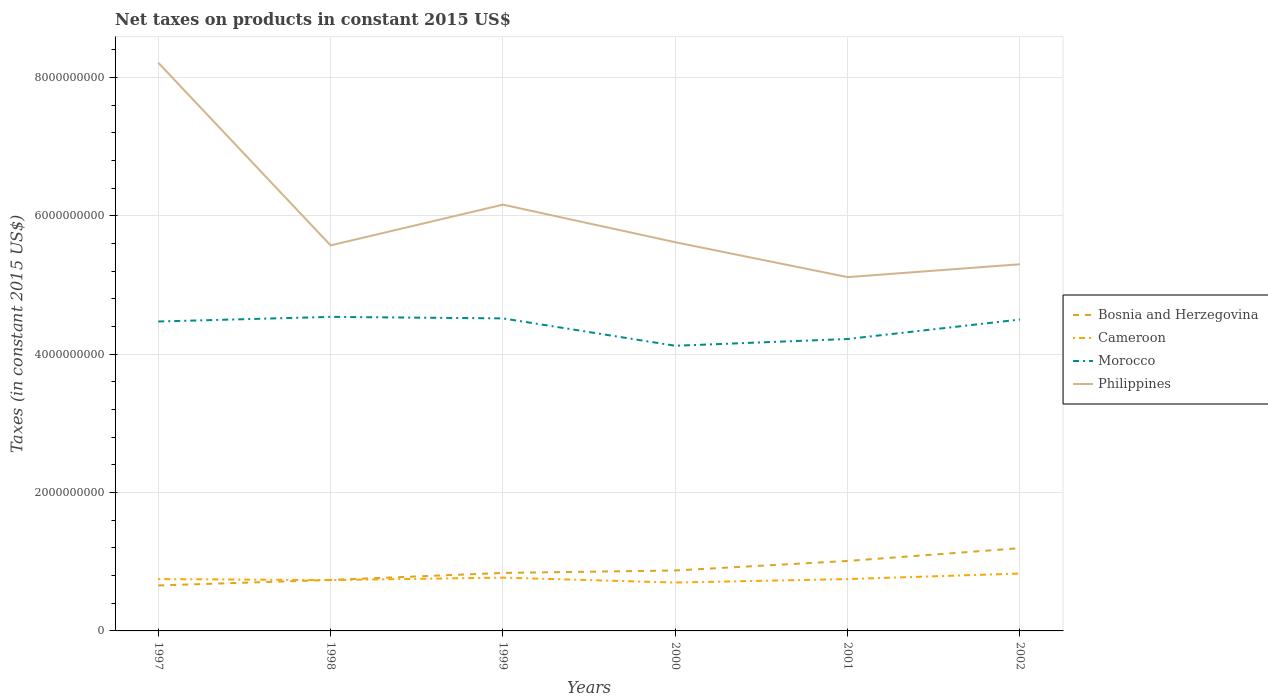Does the line corresponding to Bosnia and Herzegovina intersect with the line corresponding to Cameroon?
Provide a short and direct response. Yes. Is the number of lines equal to the number of legend labels?
Provide a succinct answer. Yes. Across all years, what is the maximum net taxes on products in Philippines?
Make the answer very short. 5.11e+09. In which year was the net taxes on products in Cameroon maximum?
Offer a very short reply. 2000. What is the total net taxes on products in Bosnia and Herzegovina in the graph?
Your response must be concise. -2.75e+08. What is the difference between the highest and the second highest net taxes on products in Bosnia and Herzegovina?
Your response must be concise. 5.39e+08. Is the net taxes on products in Philippines strictly greater than the net taxes on products in Morocco over the years?
Make the answer very short. No. How many years are there in the graph?
Ensure brevity in your answer.  6. What is the difference between two consecutive major ticks on the Y-axis?
Your response must be concise. 2.00e+09. Are the values on the major ticks of Y-axis written in scientific E-notation?
Keep it short and to the point. No. Does the graph contain grids?
Ensure brevity in your answer.  Yes. Where does the legend appear in the graph?
Provide a short and direct response. Center right. How many legend labels are there?
Your answer should be very brief. 4. How are the legend labels stacked?
Your answer should be very brief. Vertical. What is the title of the graph?
Keep it short and to the point. Net taxes on products in constant 2015 US$. What is the label or title of the X-axis?
Provide a short and direct response. Years. What is the label or title of the Y-axis?
Offer a terse response. Taxes (in constant 2015 US$). What is the Taxes (in constant 2015 US$) of Bosnia and Herzegovina in 1997?
Make the answer very short. 6.57e+08. What is the Taxes (in constant 2015 US$) in Cameroon in 1997?
Your answer should be very brief. 7.50e+08. What is the Taxes (in constant 2015 US$) of Morocco in 1997?
Give a very brief answer. 4.47e+09. What is the Taxes (in constant 2015 US$) of Philippines in 1997?
Offer a terse response. 8.21e+09. What is the Taxes (in constant 2015 US$) of Bosnia and Herzegovina in 1998?
Keep it short and to the point. 7.37e+08. What is the Taxes (in constant 2015 US$) of Cameroon in 1998?
Offer a very short reply. 7.35e+08. What is the Taxes (in constant 2015 US$) of Morocco in 1998?
Ensure brevity in your answer.  4.54e+09. What is the Taxes (in constant 2015 US$) in Philippines in 1998?
Keep it short and to the point. 5.57e+09. What is the Taxes (in constant 2015 US$) of Bosnia and Herzegovina in 1999?
Your answer should be compact. 8.38e+08. What is the Taxes (in constant 2015 US$) of Cameroon in 1999?
Your answer should be compact. 7.70e+08. What is the Taxes (in constant 2015 US$) of Morocco in 1999?
Provide a short and direct response. 4.52e+09. What is the Taxes (in constant 2015 US$) of Philippines in 1999?
Your response must be concise. 6.16e+09. What is the Taxes (in constant 2015 US$) in Bosnia and Herzegovina in 2000?
Offer a terse response. 8.74e+08. What is the Taxes (in constant 2015 US$) of Cameroon in 2000?
Ensure brevity in your answer.  6.99e+08. What is the Taxes (in constant 2015 US$) in Morocco in 2000?
Offer a very short reply. 4.12e+09. What is the Taxes (in constant 2015 US$) in Philippines in 2000?
Your answer should be very brief. 5.62e+09. What is the Taxes (in constant 2015 US$) in Bosnia and Herzegovina in 2001?
Provide a succinct answer. 1.01e+09. What is the Taxes (in constant 2015 US$) of Cameroon in 2001?
Your response must be concise. 7.50e+08. What is the Taxes (in constant 2015 US$) in Morocco in 2001?
Your answer should be very brief. 4.22e+09. What is the Taxes (in constant 2015 US$) of Philippines in 2001?
Keep it short and to the point. 5.11e+09. What is the Taxes (in constant 2015 US$) of Bosnia and Herzegovina in 2002?
Offer a very short reply. 1.20e+09. What is the Taxes (in constant 2015 US$) in Cameroon in 2002?
Provide a succinct answer. 8.30e+08. What is the Taxes (in constant 2015 US$) in Morocco in 2002?
Offer a terse response. 4.50e+09. What is the Taxes (in constant 2015 US$) in Philippines in 2002?
Make the answer very short. 5.30e+09. Across all years, what is the maximum Taxes (in constant 2015 US$) in Bosnia and Herzegovina?
Give a very brief answer. 1.20e+09. Across all years, what is the maximum Taxes (in constant 2015 US$) of Cameroon?
Offer a terse response. 8.30e+08. Across all years, what is the maximum Taxes (in constant 2015 US$) of Morocco?
Offer a very short reply. 4.54e+09. Across all years, what is the maximum Taxes (in constant 2015 US$) in Philippines?
Keep it short and to the point. 8.21e+09. Across all years, what is the minimum Taxes (in constant 2015 US$) of Bosnia and Herzegovina?
Offer a very short reply. 6.57e+08. Across all years, what is the minimum Taxes (in constant 2015 US$) in Cameroon?
Offer a terse response. 6.99e+08. Across all years, what is the minimum Taxes (in constant 2015 US$) of Morocco?
Make the answer very short. 4.12e+09. Across all years, what is the minimum Taxes (in constant 2015 US$) in Philippines?
Your answer should be very brief. 5.11e+09. What is the total Taxes (in constant 2015 US$) of Bosnia and Herzegovina in the graph?
Provide a succinct answer. 5.31e+09. What is the total Taxes (in constant 2015 US$) of Cameroon in the graph?
Provide a short and direct response. 4.53e+09. What is the total Taxes (in constant 2015 US$) of Morocco in the graph?
Your answer should be very brief. 2.64e+1. What is the total Taxes (in constant 2015 US$) of Philippines in the graph?
Your response must be concise. 3.60e+1. What is the difference between the Taxes (in constant 2015 US$) of Bosnia and Herzegovina in 1997 and that in 1998?
Your answer should be compact. -7.96e+07. What is the difference between the Taxes (in constant 2015 US$) in Cameroon in 1997 and that in 1998?
Your response must be concise. 1.47e+07. What is the difference between the Taxes (in constant 2015 US$) in Morocco in 1997 and that in 1998?
Your answer should be very brief. -6.67e+07. What is the difference between the Taxes (in constant 2015 US$) of Philippines in 1997 and that in 1998?
Your answer should be very brief. 2.64e+09. What is the difference between the Taxes (in constant 2015 US$) in Bosnia and Herzegovina in 1997 and that in 1999?
Ensure brevity in your answer.  -1.81e+08. What is the difference between the Taxes (in constant 2015 US$) in Cameroon in 1997 and that in 1999?
Keep it short and to the point. -2.08e+07. What is the difference between the Taxes (in constant 2015 US$) in Morocco in 1997 and that in 1999?
Provide a short and direct response. -4.49e+07. What is the difference between the Taxes (in constant 2015 US$) in Philippines in 1997 and that in 1999?
Keep it short and to the point. 2.05e+09. What is the difference between the Taxes (in constant 2015 US$) in Bosnia and Herzegovina in 1997 and that in 2000?
Make the answer very short. -2.17e+08. What is the difference between the Taxes (in constant 2015 US$) of Cameroon in 1997 and that in 2000?
Offer a terse response. 5.03e+07. What is the difference between the Taxes (in constant 2015 US$) in Morocco in 1997 and that in 2000?
Offer a very short reply. 3.51e+08. What is the difference between the Taxes (in constant 2015 US$) in Philippines in 1997 and that in 2000?
Give a very brief answer. 2.60e+09. What is the difference between the Taxes (in constant 2015 US$) of Bosnia and Herzegovina in 1997 and that in 2001?
Offer a very short reply. -3.54e+08. What is the difference between the Taxes (in constant 2015 US$) of Cameroon in 1997 and that in 2001?
Give a very brief answer. 3.57e+04. What is the difference between the Taxes (in constant 2015 US$) of Morocco in 1997 and that in 2001?
Ensure brevity in your answer.  2.53e+08. What is the difference between the Taxes (in constant 2015 US$) of Philippines in 1997 and that in 2001?
Give a very brief answer. 3.10e+09. What is the difference between the Taxes (in constant 2015 US$) of Bosnia and Herzegovina in 1997 and that in 2002?
Provide a succinct answer. -5.39e+08. What is the difference between the Taxes (in constant 2015 US$) in Cameroon in 1997 and that in 2002?
Ensure brevity in your answer.  -7.99e+07. What is the difference between the Taxes (in constant 2015 US$) of Morocco in 1997 and that in 2002?
Keep it short and to the point. -2.85e+07. What is the difference between the Taxes (in constant 2015 US$) in Philippines in 1997 and that in 2002?
Offer a terse response. 2.91e+09. What is the difference between the Taxes (in constant 2015 US$) of Bosnia and Herzegovina in 1998 and that in 1999?
Offer a terse response. -1.02e+08. What is the difference between the Taxes (in constant 2015 US$) in Cameroon in 1998 and that in 1999?
Your answer should be compact. -3.55e+07. What is the difference between the Taxes (in constant 2015 US$) in Morocco in 1998 and that in 1999?
Your answer should be very brief. 2.18e+07. What is the difference between the Taxes (in constant 2015 US$) in Philippines in 1998 and that in 1999?
Your response must be concise. -5.89e+08. What is the difference between the Taxes (in constant 2015 US$) of Bosnia and Herzegovina in 1998 and that in 2000?
Offer a terse response. -1.37e+08. What is the difference between the Taxes (in constant 2015 US$) of Cameroon in 1998 and that in 2000?
Provide a succinct answer. 3.56e+07. What is the difference between the Taxes (in constant 2015 US$) in Morocco in 1998 and that in 2000?
Make the answer very short. 4.18e+08. What is the difference between the Taxes (in constant 2015 US$) in Philippines in 1998 and that in 2000?
Provide a succinct answer. -4.56e+07. What is the difference between the Taxes (in constant 2015 US$) of Bosnia and Herzegovina in 1998 and that in 2001?
Offer a very short reply. -2.75e+08. What is the difference between the Taxes (in constant 2015 US$) in Cameroon in 1998 and that in 2001?
Offer a terse response. -1.47e+07. What is the difference between the Taxes (in constant 2015 US$) of Morocco in 1998 and that in 2001?
Your answer should be compact. 3.20e+08. What is the difference between the Taxes (in constant 2015 US$) in Philippines in 1998 and that in 2001?
Provide a succinct answer. 4.59e+08. What is the difference between the Taxes (in constant 2015 US$) of Bosnia and Herzegovina in 1998 and that in 2002?
Your response must be concise. -4.60e+08. What is the difference between the Taxes (in constant 2015 US$) in Cameroon in 1998 and that in 2002?
Your response must be concise. -9.46e+07. What is the difference between the Taxes (in constant 2015 US$) of Morocco in 1998 and that in 2002?
Your answer should be compact. 3.82e+07. What is the difference between the Taxes (in constant 2015 US$) in Philippines in 1998 and that in 2002?
Your answer should be very brief. 2.73e+08. What is the difference between the Taxes (in constant 2015 US$) in Bosnia and Herzegovina in 1999 and that in 2000?
Provide a short and direct response. -3.54e+07. What is the difference between the Taxes (in constant 2015 US$) in Cameroon in 1999 and that in 2000?
Your response must be concise. 7.11e+07. What is the difference between the Taxes (in constant 2015 US$) of Morocco in 1999 and that in 2000?
Your response must be concise. 3.96e+08. What is the difference between the Taxes (in constant 2015 US$) in Philippines in 1999 and that in 2000?
Provide a short and direct response. 5.43e+08. What is the difference between the Taxes (in constant 2015 US$) of Bosnia and Herzegovina in 1999 and that in 2001?
Offer a terse response. -1.73e+08. What is the difference between the Taxes (in constant 2015 US$) of Cameroon in 1999 and that in 2001?
Offer a very short reply. 2.08e+07. What is the difference between the Taxes (in constant 2015 US$) in Morocco in 1999 and that in 2001?
Your answer should be very brief. 2.98e+08. What is the difference between the Taxes (in constant 2015 US$) in Philippines in 1999 and that in 2001?
Provide a short and direct response. 1.05e+09. What is the difference between the Taxes (in constant 2015 US$) in Bosnia and Herzegovina in 1999 and that in 2002?
Make the answer very short. -3.58e+08. What is the difference between the Taxes (in constant 2015 US$) in Cameroon in 1999 and that in 2002?
Offer a very short reply. -5.92e+07. What is the difference between the Taxes (in constant 2015 US$) of Morocco in 1999 and that in 2002?
Give a very brief answer. 1.64e+07. What is the difference between the Taxes (in constant 2015 US$) in Philippines in 1999 and that in 2002?
Provide a short and direct response. 8.62e+08. What is the difference between the Taxes (in constant 2015 US$) in Bosnia and Herzegovina in 2000 and that in 2001?
Your response must be concise. -1.38e+08. What is the difference between the Taxes (in constant 2015 US$) of Cameroon in 2000 and that in 2001?
Ensure brevity in your answer.  -5.02e+07. What is the difference between the Taxes (in constant 2015 US$) in Morocco in 2000 and that in 2001?
Keep it short and to the point. -9.79e+07. What is the difference between the Taxes (in constant 2015 US$) in Philippines in 2000 and that in 2001?
Your response must be concise. 5.04e+08. What is the difference between the Taxes (in constant 2015 US$) of Bosnia and Herzegovina in 2000 and that in 2002?
Offer a terse response. -3.23e+08. What is the difference between the Taxes (in constant 2015 US$) in Cameroon in 2000 and that in 2002?
Your answer should be very brief. -1.30e+08. What is the difference between the Taxes (in constant 2015 US$) in Morocco in 2000 and that in 2002?
Keep it short and to the point. -3.79e+08. What is the difference between the Taxes (in constant 2015 US$) of Philippines in 2000 and that in 2002?
Your answer should be very brief. 3.18e+08. What is the difference between the Taxes (in constant 2015 US$) in Bosnia and Herzegovina in 2001 and that in 2002?
Your response must be concise. -1.85e+08. What is the difference between the Taxes (in constant 2015 US$) of Cameroon in 2001 and that in 2002?
Make the answer very short. -8.00e+07. What is the difference between the Taxes (in constant 2015 US$) in Morocco in 2001 and that in 2002?
Your answer should be very brief. -2.81e+08. What is the difference between the Taxes (in constant 2015 US$) of Philippines in 2001 and that in 2002?
Your answer should be compact. -1.86e+08. What is the difference between the Taxes (in constant 2015 US$) of Bosnia and Herzegovina in 1997 and the Taxes (in constant 2015 US$) of Cameroon in 1998?
Offer a terse response. -7.77e+07. What is the difference between the Taxes (in constant 2015 US$) of Bosnia and Herzegovina in 1997 and the Taxes (in constant 2015 US$) of Morocco in 1998?
Provide a short and direct response. -3.88e+09. What is the difference between the Taxes (in constant 2015 US$) in Bosnia and Herzegovina in 1997 and the Taxes (in constant 2015 US$) in Philippines in 1998?
Your answer should be very brief. -4.92e+09. What is the difference between the Taxes (in constant 2015 US$) in Cameroon in 1997 and the Taxes (in constant 2015 US$) in Morocco in 1998?
Ensure brevity in your answer.  -3.79e+09. What is the difference between the Taxes (in constant 2015 US$) in Cameroon in 1997 and the Taxes (in constant 2015 US$) in Philippines in 1998?
Your response must be concise. -4.82e+09. What is the difference between the Taxes (in constant 2015 US$) in Morocco in 1997 and the Taxes (in constant 2015 US$) in Philippines in 1998?
Give a very brief answer. -1.10e+09. What is the difference between the Taxes (in constant 2015 US$) in Bosnia and Herzegovina in 1997 and the Taxes (in constant 2015 US$) in Cameroon in 1999?
Provide a succinct answer. -1.13e+08. What is the difference between the Taxes (in constant 2015 US$) in Bosnia and Herzegovina in 1997 and the Taxes (in constant 2015 US$) in Morocco in 1999?
Give a very brief answer. -3.86e+09. What is the difference between the Taxes (in constant 2015 US$) of Bosnia and Herzegovina in 1997 and the Taxes (in constant 2015 US$) of Philippines in 1999?
Give a very brief answer. -5.51e+09. What is the difference between the Taxes (in constant 2015 US$) in Cameroon in 1997 and the Taxes (in constant 2015 US$) in Morocco in 1999?
Give a very brief answer. -3.77e+09. What is the difference between the Taxes (in constant 2015 US$) in Cameroon in 1997 and the Taxes (in constant 2015 US$) in Philippines in 1999?
Offer a very short reply. -5.41e+09. What is the difference between the Taxes (in constant 2015 US$) of Morocco in 1997 and the Taxes (in constant 2015 US$) of Philippines in 1999?
Offer a terse response. -1.69e+09. What is the difference between the Taxes (in constant 2015 US$) of Bosnia and Herzegovina in 1997 and the Taxes (in constant 2015 US$) of Cameroon in 2000?
Your response must be concise. -4.21e+07. What is the difference between the Taxes (in constant 2015 US$) in Bosnia and Herzegovina in 1997 and the Taxes (in constant 2015 US$) in Morocco in 2000?
Offer a very short reply. -3.47e+09. What is the difference between the Taxes (in constant 2015 US$) of Bosnia and Herzegovina in 1997 and the Taxes (in constant 2015 US$) of Philippines in 2000?
Provide a succinct answer. -4.96e+09. What is the difference between the Taxes (in constant 2015 US$) in Cameroon in 1997 and the Taxes (in constant 2015 US$) in Morocco in 2000?
Your answer should be very brief. -3.37e+09. What is the difference between the Taxes (in constant 2015 US$) of Cameroon in 1997 and the Taxes (in constant 2015 US$) of Philippines in 2000?
Your response must be concise. -4.87e+09. What is the difference between the Taxes (in constant 2015 US$) of Morocco in 1997 and the Taxes (in constant 2015 US$) of Philippines in 2000?
Provide a short and direct response. -1.15e+09. What is the difference between the Taxes (in constant 2015 US$) of Bosnia and Herzegovina in 1997 and the Taxes (in constant 2015 US$) of Cameroon in 2001?
Your answer should be very brief. -9.23e+07. What is the difference between the Taxes (in constant 2015 US$) of Bosnia and Herzegovina in 1997 and the Taxes (in constant 2015 US$) of Morocco in 2001?
Keep it short and to the point. -3.56e+09. What is the difference between the Taxes (in constant 2015 US$) of Bosnia and Herzegovina in 1997 and the Taxes (in constant 2015 US$) of Philippines in 2001?
Your answer should be compact. -4.46e+09. What is the difference between the Taxes (in constant 2015 US$) of Cameroon in 1997 and the Taxes (in constant 2015 US$) of Morocco in 2001?
Your answer should be very brief. -3.47e+09. What is the difference between the Taxes (in constant 2015 US$) of Cameroon in 1997 and the Taxes (in constant 2015 US$) of Philippines in 2001?
Offer a very short reply. -4.37e+09. What is the difference between the Taxes (in constant 2015 US$) in Morocco in 1997 and the Taxes (in constant 2015 US$) in Philippines in 2001?
Provide a short and direct response. -6.42e+08. What is the difference between the Taxes (in constant 2015 US$) in Bosnia and Herzegovina in 1997 and the Taxes (in constant 2015 US$) in Cameroon in 2002?
Make the answer very short. -1.72e+08. What is the difference between the Taxes (in constant 2015 US$) in Bosnia and Herzegovina in 1997 and the Taxes (in constant 2015 US$) in Morocco in 2002?
Make the answer very short. -3.84e+09. What is the difference between the Taxes (in constant 2015 US$) of Bosnia and Herzegovina in 1997 and the Taxes (in constant 2015 US$) of Philippines in 2002?
Provide a short and direct response. -4.64e+09. What is the difference between the Taxes (in constant 2015 US$) in Cameroon in 1997 and the Taxes (in constant 2015 US$) in Morocco in 2002?
Give a very brief answer. -3.75e+09. What is the difference between the Taxes (in constant 2015 US$) of Cameroon in 1997 and the Taxes (in constant 2015 US$) of Philippines in 2002?
Provide a succinct answer. -4.55e+09. What is the difference between the Taxes (in constant 2015 US$) in Morocco in 1997 and the Taxes (in constant 2015 US$) in Philippines in 2002?
Ensure brevity in your answer.  -8.28e+08. What is the difference between the Taxes (in constant 2015 US$) of Bosnia and Herzegovina in 1998 and the Taxes (in constant 2015 US$) of Cameroon in 1999?
Your answer should be very brief. -3.35e+07. What is the difference between the Taxes (in constant 2015 US$) of Bosnia and Herzegovina in 1998 and the Taxes (in constant 2015 US$) of Morocco in 1999?
Ensure brevity in your answer.  -3.78e+09. What is the difference between the Taxes (in constant 2015 US$) in Bosnia and Herzegovina in 1998 and the Taxes (in constant 2015 US$) in Philippines in 1999?
Keep it short and to the point. -5.43e+09. What is the difference between the Taxes (in constant 2015 US$) of Cameroon in 1998 and the Taxes (in constant 2015 US$) of Morocco in 1999?
Your answer should be compact. -3.78e+09. What is the difference between the Taxes (in constant 2015 US$) in Cameroon in 1998 and the Taxes (in constant 2015 US$) in Philippines in 1999?
Offer a terse response. -5.43e+09. What is the difference between the Taxes (in constant 2015 US$) of Morocco in 1998 and the Taxes (in constant 2015 US$) of Philippines in 1999?
Keep it short and to the point. -1.62e+09. What is the difference between the Taxes (in constant 2015 US$) in Bosnia and Herzegovina in 1998 and the Taxes (in constant 2015 US$) in Cameroon in 2000?
Offer a terse response. 3.76e+07. What is the difference between the Taxes (in constant 2015 US$) in Bosnia and Herzegovina in 1998 and the Taxes (in constant 2015 US$) in Morocco in 2000?
Your answer should be very brief. -3.39e+09. What is the difference between the Taxes (in constant 2015 US$) of Bosnia and Herzegovina in 1998 and the Taxes (in constant 2015 US$) of Philippines in 2000?
Your response must be concise. -4.88e+09. What is the difference between the Taxes (in constant 2015 US$) in Cameroon in 1998 and the Taxes (in constant 2015 US$) in Morocco in 2000?
Your answer should be compact. -3.39e+09. What is the difference between the Taxes (in constant 2015 US$) of Cameroon in 1998 and the Taxes (in constant 2015 US$) of Philippines in 2000?
Your response must be concise. -4.88e+09. What is the difference between the Taxes (in constant 2015 US$) in Morocco in 1998 and the Taxes (in constant 2015 US$) in Philippines in 2000?
Your answer should be compact. -1.08e+09. What is the difference between the Taxes (in constant 2015 US$) of Bosnia and Herzegovina in 1998 and the Taxes (in constant 2015 US$) of Cameroon in 2001?
Ensure brevity in your answer.  -1.27e+07. What is the difference between the Taxes (in constant 2015 US$) of Bosnia and Herzegovina in 1998 and the Taxes (in constant 2015 US$) of Morocco in 2001?
Make the answer very short. -3.48e+09. What is the difference between the Taxes (in constant 2015 US$) in Bosnia and Herzegovina in 1998 and the Taxes (in constant 2015 US$) in Philippines in 2001?
Offer a terse response. -4.38e+09. What is the difference between the Taxes (in constant 2015 US$) of Cameroon in 1998 and the Taxes (in constant 2015 US$) of Morocco in 2001?
Give a very brief answer. -3.49e+09. What is the difference between the Taxes (in constant 2015 US$) of Cameroon in 1998 and the Taxes (in constant 2015 US$) of Philippines in 2001?
Offer a terse response. -4.38e+09. What is the difference between the Taxes (in constant 2015 US$) of Morocco in 1998 and the Taxes (in constant 2015 US$) of Philippines in 2001?
Your answer should be compact. -5.75e+08. What is the difference between the Taxes (in constant 2015 US$) of Bosnia and Herzegovina in 1998 and the Taxes (in constant 2015 US$) of Cameroon in 2002?
Your response must be concise. -9.27e+07. What is the difference between the Taxes (in constant 2015 US$) in Bosnia and Herzegovina in 1998 and the Taxes (in constant 2015 US$) in Morocco in 2002?
Provide a succinct answer. -3.76e+09. What is the difference between the Taxes (in constant 2015 US$) in Bosnia and Herzegovina in 1998 and the Taxes (in constant 2015 US$) in Philippines in 2002?
Ensure brevity in your answer.  -4.56e+09. What is the difference between the Taxes (in constant 2015 US$) of Cameroon in 1998 and the Taxes (in constant 2015 US$) of Morocco in 2002?
Provide a short and direct response. -3.77e+09. What is the difference between the Taxes (in constant 2015 US$) in Cameroon in 1998 and the Taxes (in constant 2015 US$) in Philippines in 2002?
Offer a very short reply. -4.57e+09. What is the difference between the Taxes (in constant 2015 US$) in Morocco in 1998 and the Taxes (in constant 2015 US$) in Philippines in 2002?
Make the answer very short. -7.61e+08. What is the difference between the Taxes (in constant 2015 US$) of Bosnia and Herzegovina in 1999 and the Taxes (in constant 2015 US$) of Cameroon in 2000?
Offer a terse response. 1.39e+08. What is the difference between the Taxes (in constant 2015 US$) in Bosnia and Herzegovina in 1999 and the Taxes (in constant 2015 US$) in Morocco in 2000?
Offer a terse response. -3.28e+09. What is the difference between the Taxes (in constant 2015 US$) of Bosnia and Herzegovina in 1999 and the Taxes (in constant 2015 US$) of Philippines in 2000?
Your answer should be very brief. -4.78e+09. What is the difference between the Taxes (in constant 2015 US$) of Cameroon in 1999 and the Taxes (in constant 2015 US$) of Morocco in 2000?
Your answer should be very brief. -3.35e+09. What is the difference between the Taxes (in constant 2015 US$) of Cameroon in 1999 and the Taxes (in constant 2015 US$) of Philippines in 2000?
Make the answer very short. -4.85e+09. What is the difference between the Taxes (in constant 2015 US$) of Morocco in 1999 and the Taxes (in constant 2015 US$) of Philippines in 2000?
Offer a terse response. -1.10e+09. What is the difference between the Taxes (in constant 2015 US$) of Bosnia and Herzegovina in 1999 and the Taxes (in constant 2015 US$) of Cameroon in 2001?
Provide a succinct answer. 8.88e+07. What is the difference between the Taxes (in constant 2015 US$) in Bosnia and Herzegovina in 1999 and the Taxes (in constant 2015 US$) in Morocco in 2001?
Offer a very short reply. -3.38e+09. What is the difference between the Taxes (in constant 2015 US$) of Bosnia and Herzegovina in 1999 and the Taxes (in constant 2015 US$) of Philippines in 2001?
Provide a short and direct response. -4.28e+09. What is the difference between the Taxes (in constant 2015 US$) of Cameroon in 1999 and the Taxes (in constant 2015 US$) of Morocco in 2001?
Provide a short and direct response. -3.45e+09. What is the difference between the Taxes (in constant 2015 US$) of Cameroon in 1999 and the Taxes (in constant 2015 US$) of Philippines in 2001?
Offer a terse response. -4.34e+09. What is the difference between the Taxes (in constant 2015 US$) of Morocco in 1999 and the Taxes (in constant 2015 US$) of Philippines in 2001?
Keep it short and to the point. -5.97e+08. What is the difference between the Taxes (in constant 2015 US$) in Bosnia and Herzegovina in 1999 and the Taxes (in constant 2015 US$) in Cameroon in 2002?
Provide a short and direct response. 8.86e+06. What is the difference between the Taxes (in constant 2015 US$) in Bosnia and Herzegovina in 1999 and the Taxes (in constant 2015 US$) in Morocco in 2002?
Your answer should be compact. -3.66e+09. What is the difference between the Taxes (in constant 2015 US$) in Bosnia and Herzegovina in 1999 and the Taxes (in constant 2015 US$) in Philippines in 2002?
Your answer should be very brief. -4.46e+09. What is the difference between the Taxes (in constant 2015 US$) in Cameroon in 1999 and the Taxes (in constant 2015 US$) in Morocco in 2002?
Provide a short and direct response. -3.73e+09. What is the difference between the Taxes (in constant 2015 US$) in Cameroon in 1999 and the Taxes (in constant 2015 US$) in Philippines in 2002?
Your answer should be compact. -4.53e+09. What is the difference between the Taxes (in constant 2015 US$) in Morocco in 1999 and the Taxes (in constant 2015 US$) in Philippines in 2002?
Your response must be concise. -7.83e+08. What is the difference between the Taxes (in constant 2015 US$) of Bosnia and Herzegovina in 2000 and the Taxes (in constant 2015 US$) of Cameroon in 2001?
Provide a short and direct response. 1.24e+08. What is the difference between the Taxes (in constant 2015 US$) of Bosnia and Herzegovina in 2000 and the Taxes (in constant 2015 US$) of Morocco in 2001?
Your response must be concise. -3.35e+09. What is the difference between the Taxes (in constant 2015 US$) in Bosnia and Herzegovina in 2000 and the Taxes (in constant 2015 US$) in Philippines in 2001?
Make the answer very short. -4.24e+09. What is the difference between the Taxes (in constant 2015 US$) of Cameroon in 2000 and the Taxes (in constant 2015 US$) of Morocco in 2001?
Your answer should be very brief. -3.52e+09. What is the difference between the Taxes (in constant 2015 US$) of Cameroon in 2000 and the Taxes (in constant 2015 US$) of Philippines in 2001?
Provide a short and direct response. -4.42e+09. What is the difference between the Taxes (in constant 2015 US$) in Morocco in 2000 and the Taxes (in constant 2015 US$) in Philippines in 2001?
Provide a succinct answer. -9.92e+08. What is the difference between the Taxes (in constant 2015 US$) in Bosnia and Herzegovina in 2000 and the Taxes (in constant 2015 US$) in Cameroon in 2002?
Offer a terse response. 4.43e+07. What is the difference between the Taxes (in constant 2015 US$) in Bosnia and Herzegovina in 2000 and the Taxes (in constant 2015 US$) in Morocco in 2002?
Offer a very short reply. -3.63e+09. What is the difference between the Taxes (in constant 2015 US$) of Bosnia and Herzegovina in 2000 and the Taxes (in constant 2015 US$) of Philippines in 2002?
Give a very brief answer. -4.43e+09. What is the difference between the Taxes (in constant 2015 US$) of Cameroon in 2000 and the Taxes (in constant 2015 US$) of Morocco in 2002?
Provide a succinct answer. -3.80e+09. What is the difference between the Taxes (in constant 2015 US$) of Cameroon in 2000 and the Taxes (in constant 2015 US$) of Philippines in 2002?
Ensure brevity in your answer.  -4.60e+09. What is the difference between the Taxes (in constant 2015 US$) in Morocco in 2000 and the Taxes (in constant 2015 US$) in Philippines in 2002?
Ensure brevity in your answer.  -1.18e+09. What is the difference between the Taxes (in constant 2015 US$) in Bosnia and Herzegovina in 2001 and the Taxes (in constant 2015 US$) in Cameroon in 2002?
Give a very brief answer. 1.82e+08. What is the difference between the Taxes (in constant 2015 US$) of Bosnia and Herzegovina in 2001 and the Taxes (in constant 2015 US$) of Morocco in 2002?
Keep it short and to the point. -3.49e+09. What is the difference between the Taxes (in constant 2015 US$) in Bosnia and Herzegovina in 2001 and the Taxes (in constant 2015 US$) in Philippines in 2002?
Make the answer very short. -4.29e+09. What is the difference between the Taxes (in constant 2015 US$) of Cameroon in 2001 and the Taxes (in constant 2015 US$) of Morocco in 2002?
Provide a short and direct response. -3.75e+09. What is the difference between the Taxes (in constant 2015 US$) in Cameroon in 2001 and the Taxes (in constant 2015 US$) in Philippines in 2002?
Offer a terse response. -4.55e+09. What is the difference between the Taxes (in constant 2015 US$) in Morocco in 2001 and the Taxes (in constant 2015 US$) in Philippines in 2002?
Ensure brevity in your answer.  -1.08e+09. What is the average Taxes (in constant 2015 US$) in Bosnia and Herzegovina per year?
Keep it short and to the point. 8.86e+08. What is the average Taxes (in constant 2015 US$) of Cameroon per year?
Provide a short and direct response. 7.56e+08. What is the average Taxes (in constant 2015 US$) in Morocco per year?
Make the answer very short. 4.40e+09. What is the average Taxes (in constant 2015 US$) of Philippines per year?
Your response must be concise. 6.00e+09. In the year 1997, what is the difference between the Taxes (in constant 2015 US$) in Bosnia and Herzegovina and Taxes (in constant 2015 US$) in Cameroon?
Provide a short and direct response. -9.24e+07. In the year 1997, what is the difference between the Taxes (in constant 2015 US$) of Bosnia and Herzegovina and Taxes (in constant 2015 US$) of Morocco?
Ensure brevity in your answer.  -3.82e+09. In the year 1997, what is the difference between the Taxes (in constant 2015 US$) in Bosnia and Herzegovina and Taxes (in constant 2015 US$) in Philippines?
Make the answer very short. -7.56e+09. In the year 1997, what is the difference between the Taxes (in constant 2015 US$) in Cameroon and Taxes (in constant 2015 US$) in Morocco?
Make the answer very short. -3.72e+09. In the year 1997, what is the difference between the Taxes (in constant 2015 US$) of Cameroon and Taxes (in constant 2015 US$) of Philippines?
Ensure brevity in your answer.  -7.47e+09. In the year 1997, what is the difference between the Taxes (in constant 2015 US$) of Morocco and Taxes (in constant 2015 US$) of Philippines?
Provide a succinct answer. -3.74e+09. In the year 1998, what is the difference between the Taxes (in constant 2015 US$) in Bosnia and Herzegovina and Taxes (in constant 2015 US$) in Cameroon?
Offer a terse response. 1.97e+06. In the year 1998, what is the difference between the Taxes (in constant 2015 US$) of Bosnia and Herzegovina and Taxes (in constant 2015 US$) of Morocco?
Offer a terse response. -3.80e+09. In the year 1998, what is the difference between the Taxes (in constant 2015 US$) in Bosnia and Herzegovina and Taxes (in constant 2015 US$) in Philippines?
Provide a succinct answer. -4.84e+09. In the year 1998, what is the difference between the Taxes (in constant 2015 US$) of Cameroon and Taxes (in constant 2015 US$) of Morocco?
Offer a very short reply. -3.81e+09. In the year 1998, what is the difference between the Taxes (in constant 2015 US$) in Cameroon and Taxes (in constant 2015 US$) in Philippines?
Offer a very short reply. -4.84e+09. In the year 1998, what is the difference between the Taxes (in constant 2015 US$) of Morocco and Taxes (in constant 2015 US$) of Philippines?
Give a very brief answer. -1.03e+09. In the year 1999, what is the difference between the Taxes (in constant 2015 US$) of Bosnia and Herzegovina and Taxes (in constant 2015 US$) of Cameroon?
Ensure brevity in your answer.  6.80e+07. In the year 1999, what is the difference between the Taxes (in constant 2015 US$) in Bosnia and Herzegovina and Taxes (in constant 2015 US$) in Morocco?
Your answer should be compact. -3.68e+09. In the year 1999, what is the difference between the Taxes (in constant 2015 US$) in Bosnia and Herzegovina and Taxes (in constant 2015 US$) in Philippines?
Your answer should be compact. -5.32e+09. In the year 1999, what is the difference between the Taxes (in constant 2015 US$) in Cameroon and Taxes (in constant 2015 US$) in Morocco?
Your response must be concise. -3.75e+09. In the year 1999, what is the difference between the Taxes (in constant 2015 US$) of Cameroon and Taxes (in constant 2015 US$) of Philippines?
Make the answer very short. -5.39e+09. In the year 1999, what is the difference between the Taxes (in constant 2015 US$) in Morocco and Taxes (in constant 2015 US$) in Philippines?
Keep it short and to the point. -1.64e+09. In the year 2000, what is the difference between the Taxes (in constant 2015 US$) in Bosnia and Herzegovina and Taxes (in constant 2015 US$) in Cameroon?
Your answer should be compact. 1.74e+08. In the year 2000, what is the difference between the Taxes (in constant 2015 US$) of Bosnia and Herzegovina and Taxes (in constant 2015 US$) of Morocco?
Your answer should be compact. -3.25e+09. In the year 2000, what is the difference between the Taxes (in constant 2015 US$) in Bosnia and Herzegovina and Taxes (in constant 2015 US$) in Philippines?
Your answer should be compact. -4.75e+09. In the year 2000, what is the difference between the Taxes (in constant 2015 US$) in Cameroon and Taxes (in constant 2015 US$) in Morocco?
Make the answer very short. -3.42e+09. In the year 2000, what is the difference between the Taxes (in constant 2015 US$) of Cameroon and Taxes (in constant 2015 US$) of Philippines?
Ensure brevity in your answer.  -4.92e+09. In the year 2000, what is the difference between the Taxes (in constant 2015 US$) of Morocco and Taxes (in constant 2015 US$) of Philippines?
Give a very brief answer. -1.50e+09. In the year 2001, what is the difference between the Taxes (in constant 2015 US$) in Bosnia and Herzegovina and Taxes (in constant 2015 US$) in Cameroon?
Your answer should be very brief. 2.62e+08. In the year 2001, what is the difference between the Taxes (in constant 2015 US$) of Bosnia and Herzegovina and Taxes (in constant 2015 US$) of Morocco?
Offer a very short reply. -3.21e+09. In the year 2001, what is the difference between the Taxes (in constant 2015 US$) in Bosnia and Herzegovina and Taxes (in constant 2015 US$) in Philippines?
Keep it short and to the point. -4.10e+09. In the year 2001, what is the difference between the Taxes (in constant 2015 US$) in Cameroon and Taxes (in constant 2015 US$) in Morocco?
Provide a short and direct response. -3.47e+09. In the year 2001, what is the difference between the Taxes (in constant 2015 US$) of Cameroon and Taxes (in constant 2015 US$) of Philippines?
Your answer should be very brief. -4.37e+09. In the year 2001, what is the difference between the Taxes (in constant 2015 US$) of Morocco and Taxes (in constant 2015 US$) of Philippines?
Provide a short and direct response. -8.95e+08. In the year 2002, what is the difference between the Taxes (in constant 2015 US$) in Bosnia and Herzegovina and Taxes (in constant 2015 US$) in Cameroon?
Your answer should be very brief. 3.67e+08. In the year 2002, what is the difference between the Taxes (in constant 2015 US$) of Bosnia and Herzegovina and Taxes (in constant 2015 US$) of Morocco?
Provide a short and direct response. -3.31e+09. In the year 2002, what is the difference between the Taxes (in constant 2015 US$) of Bosnia and Herzegovina and Taxes (in constant 2015 US$) of Philippines?
Provide a short and direct response. -4.10e+09. In the year 2002, what is the difference between the Taxes (in constant 2015 US$) in Cameroon and Taxes (in constant 2015 US$) in Morocco?
Make the answer very short. -3.67e+09. In the year 2002, what is the difference between the Taxes (in constant 2015 US$) in Cameroon and Taxes (in constant 2015 US$) in Philippines?
Ensure brevity in your answer.  -4.47e+09. In the year 2002, what is the difference between the Taxes (in constant 2015 US$) of Morocco and Taxes (in constant 2015 US$) of Philippines?
Ensure brevity in your answer.  -7.99e+08. What is the ratio of the Taxes (in constant 2015 US$) of Bosnia and Herzegovina in 1997 to that in 1998?
Offer a terse response. 0.89. What is the ratio of the Taxes (in constant 2015 US$) in Cameroon in 1997 to that in 1998?
Your answer should be very brief. 1.02. What is the ratio of the Taxes (in constant 2015 US$) of Morocco in 1997 to that in 1998?
Ensure brevity in your answer.  0.99. What is the ratio of the Taxes (in constant 2015 US$) of Philippines in 1997 to that in 1998?
Offer a very short reply. 1.47. What is the ratio of the Taxes (in constant 2015 US$) in Bosnia and Herzegovina in 1997 to that in 1999?
Provide a short and direct response. 0.78. What is the ratio of the Taxes (in constant 2015 US$) of Morocco in 1997 to that in 1999?
Your answer should be very brief. 0.99. What is the ratio of the Taxes (in constant 2015 US$) of Philippines in 1997 to that in 1999?
Your answer should be very brief. 1.33. What is the ratio of the Taxes (in constant 2015 US$) of Bosnia and Herzegovina in 1997 to that in 2000?
Offer a terse response. 0.75. What is the ratio of the Taxes (in constant 2015 US$) in Cameroon in 1997 to that in 2000?
Give a very brief answer. 1.07. What is the ratio of the Taxes (in constant 2015 US$) of Morocco in 1997 to that in 2000?
Make the answer very short. 1.09. What is the ratio of the Taxes (in constant 2015 US$) in Philippines in 1997 to that in 2000?
Give a very brief answer. 1.46. What is the ratio of the Taxes (in constant 2015 US$) of Bosnia and Herzegovina in 1997 to that in 2001?
Offer a terse response. 0.65. What is the ratio of the Taxes (in constant 2015 US$) in Morocco in 1997 to that in 2001?
Make the answer very short. 1.06. What is the ratio of the Taxes (in constant 2015 US$) of Philippines in 1997 to that in 2001?
Give a very brief answer. 1.61. What is the ratio of the Taxes (in constant 2015 US$) in Bosnia and Herzegovina in 1997 to that in 2002?
Your response must be concise. 0.55. What is the ratio of the Taxes (in constant 2015 US$) of Cameroon in 1997 to that in 2002?
Provide a short and direct response. 0.9. What is the ratio of the Taxes (in constant 2015 US$) in Philippines in 1997 to that in 2002?
Your answer should be very brief. 1.55. What is the ratio of the Taxes (in constant 2015 US$) of Bosnia and Herzegovina in 1998 to that in 1999?
Offer a very short reply. 0.88. What is the ratio of the Taxes (in constant 2015 US$) of Cameroon in 1998 to that in 1999?
Offer a very short reply. 0.95. What is the ratio of the Taxes (in constant 2015 US$) in Morocco in 1998 to that in 1999?
Make the answer very short. 1. What is the ratio of the Taxes (in constant 2015 US$) in Philippines in 1998 to that in 1999?
Offer a very short reply. 0.9. What is the ratio of the Taxes (in constant 2015 US$) of Bosnia and Herzegovina in 1998 to that in 2000?
Provide a succinct answer. 0.84. What is the ratio of the Taxes (in constant 2015 US$) in Cameroon in 1998 to that in 2000?
Give a very brief answer. 1.05. What is the ratio of the Taxes (in constant 2015 US$) of Morocco in 1998 to that in 2000?
Make the answer very short. 1.1. What is the ratio of the Taxes (in constant 2015 US$) of Bosnia and Herzegovina in 1998 to that in 2001?
Give a very brief answer. 0.73. What is the ratio of the Taxes (in constant 2015 US$) of Cameroon in 1998 to that in 2001?
Ensure brevity in your answer.  0.98. What is the ratio of the Taxes (in constant 2015 US$) in Morocco in 1998 to that in 2001?
Provide a short and direct response. 1.08. What is the ratio of the Taxes (in constant 2015 US$) of Philippines in 1998 to that in 2001?
Your answer should be very brief. 1.09. What is the ratio of the Taxes (in constant 2015 US$) of Bosnia and Herzegovina in 1998 to that in 2002?
Give a very brief answer. 0.62. What is the ratio of the Taxes (in constant 2015 US$) in Cameroon in 1998 to that in 2002?
Provide a succinct answer. 0.89. What is the ratio of the Taxes (in constant 2015 US$) of Morocco in 1998 to that in 2002?
Offer a very short reply. 1.01. What is the ratio of the Taxes (in constant 2015 US$) in Philippines in 1998 to that in 2002?
Offer a very short reply. 1.05. What is the ratio of the Taxes (in constant 2015 US$) of Bosnia and Herzegovina in 1999 to that in 2000?
Your answer should be compact. 0.96. What is the ratio of the Taxes (in constant 2015 US$) of Cameroon in 1999 to that in 2000?
Keep it short and to the point. 1.1. What is the ratio of the Taxes (in constant 2015 US$) of Morocco in 1999 to that in 2000?
Your answer should be compact. 1.1. What is the ratio of the Taxes (in constant 2015 US$) in Philippines in 1999 to that in 2000?
Your answer should be compact. 1.1. What is the ratio of the Taxes (in constant 2015 US$) of Bosnia and Herzegovina in 1999 to that in 2001?
Provide a succinct answer. 0.83. What is the ratio of the Taxes (in constant 2015 US$) in Cameroon in 1999 to that in 2001?
Your answer should be compact. 1.03. What is the ratio of the Taxes (in constant 2015 US$) in Morocco in 1999 to that in 2001?
Ensure brevity in your answer.  1.07. What is the ratio of the Taxes (in constant 2015 US$) of Philippines in 1999 to that in 2001?
Your answer should be very brief. 1.2. What is the ratio of the Taxes (in constant 2015 US$) in Bosnia and Herzegovina in 1999 to that in 2002?
Give a very brief answer. 0.7. What is the ratio of the Taxes (in constant 2015 US$) in Cameroon in 1999 to that in 2002?
Your response must be concise. 0.93. What is the ratio of the Taxes (in constant 2015 US$) of Philippines in 1999 to that in 2002?
Keep it short and to the point. 1.16. What is the ratio of the Taxes (in constant 2015 US$) of Bosnia and Herzegovina in 2000 to that in 2001?
Make the answer very short. 0.86. What is the ratio of the Taxes (in constant 2015 US$) in Cameroon in 2000 to that in 2001?
Your answer should be very brief. 0.93. What is the ratio of the Taxes (in constant 2015 US$) of Morocco in 2000 to that in 2001?
Provide a short and direct response. 0.98. What is the ratio of the Taxes (in constant 2015 US$) in Philippines in 2000 to that in 2001?
Your answer should be very brief. 1.1. What is the ratio of the Taxes (in constant 2015 US$) of Bosnia and Herzegovina in 2000 to that in 2002?
Provide a short and direct response. 0.73. What is the ratio of the Taxes (in constant 2015 US$) of Cameroon in 2000 to that in 2002?
Offer a terse response. 0.84. What is the ratio of the Taxes (in constant 2015 US$) in Morocco in 2000 to that in 2002?
Keep it short and to the point. 0.92. What is the ratio of the Taxes (in constant 2015 US$) in Philippines in 2000 to that in 2002?
Offer a terse response. 1.06. What is the ratio of the Taxes (in constant 2015 US$) of Bosnia and Herzegovina in 2001 to that in 2002?
Provide a short and direct response. 0.85. What is the ratio of the Taxes (in constant 2015 US$) in Cameroon in 2001 to that in 2002?
Your answer should be compact. 0.9. What is the ratio of the Taxes (in constant 2015 US$) of Morocco in 2001 to that in 2002?
Offer a very short reply. 0.94. What is the ratio of the Taxes (in constant 2015 US$) in Philippines in 2001 to that in 2002?
Your answer should be very brief. 0.96. What is the difference between the highest and the second highest Taxes (in constant 2015 US$) in Bosnia and Herzegovina?
Your answer should be compact. 1.85e+08. What is the difference between the highest and the second highest Taxes (in constant 2015 US$) of Cameroon?
Provide a succinct answer. 5.92e+07. What is the difference between the highest and the second highest Taxes (in constant 2015 US$) of Morocco?
Keep it short and to the point. 2.18e+07. What is the difference between the highest and the second highest Taxes (in constant 2015 US$) of Philippines?
Give a very brief answer. 2.05e+09. What is the difference between the highest and the lowest Taxes (in constant 2015 US$) of Bosnia and Herzegovina?
Give a very brief answer. 5.39e+08. What is the difference between the highest and the lowest Taxes (in constant 2015 US$) of Cameroon?
Give a very brief answer. 1.30e+08. What is the difference between the highest and the lowest Taxes (in constant 2015 US$) of Morocco?
Keep it short and to the point. 4.18e+08. What is the difference between the highest and the lowest Taxes (in constant 2015 US$) of Philippines?
Your response must be concise. 3.10e+09. 